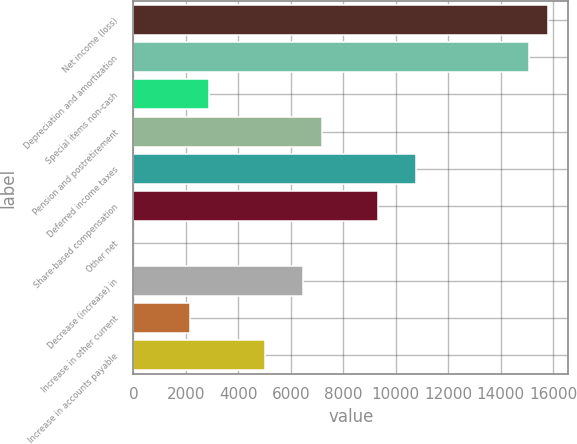Convert chart to OTSL. <chart><loc_0><loc_0><loc_500><loc_500><bar_chart><fcel>Net income (loss)<fcel>Depreciation and amortization<fcel>Special items non-cash<fcel>Pension and postretirement<fcel>Deferred income taxes<fcel>Share-based compensation<fcel>Other net<fcel>Decrease (increase) in<fcel>Increase in other current<fcel>Increase in accounts payable<nl><fcel>15790.2<fcel>15072.6<fcel>2873.4<fcel>7179<fcel>10767<fcel>9331.8<fcel>3<fcel>6461.4<fcel>2155.8<fcel>5026.2<nl></chart> 